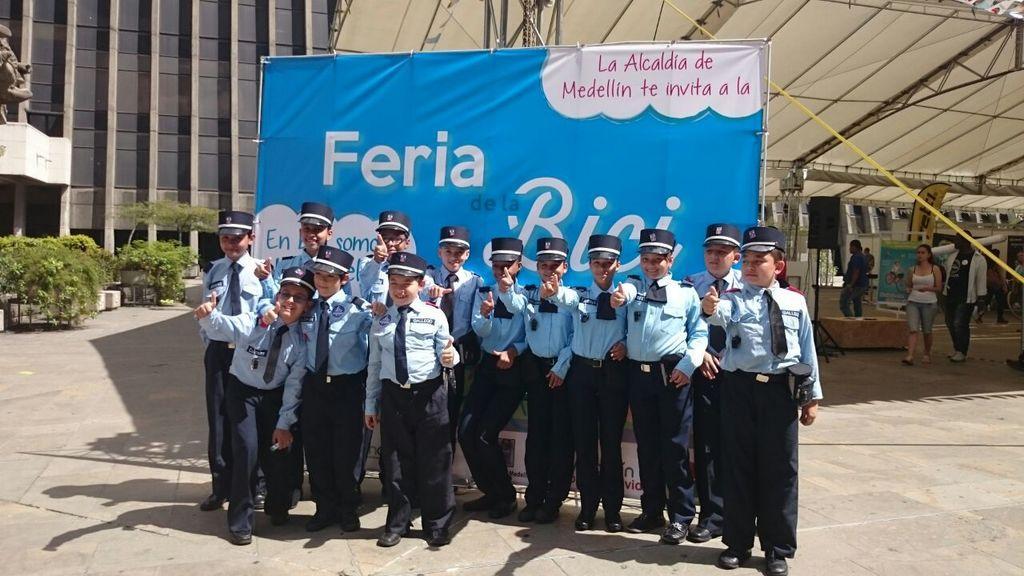In one or two sentences, can you explain what this image depicts? This image consists of a building on the left side. There are bushes on the left side. There are some persons standing in the middle. They are children. There is a banner behind them. There are some persons walking on the right side. 